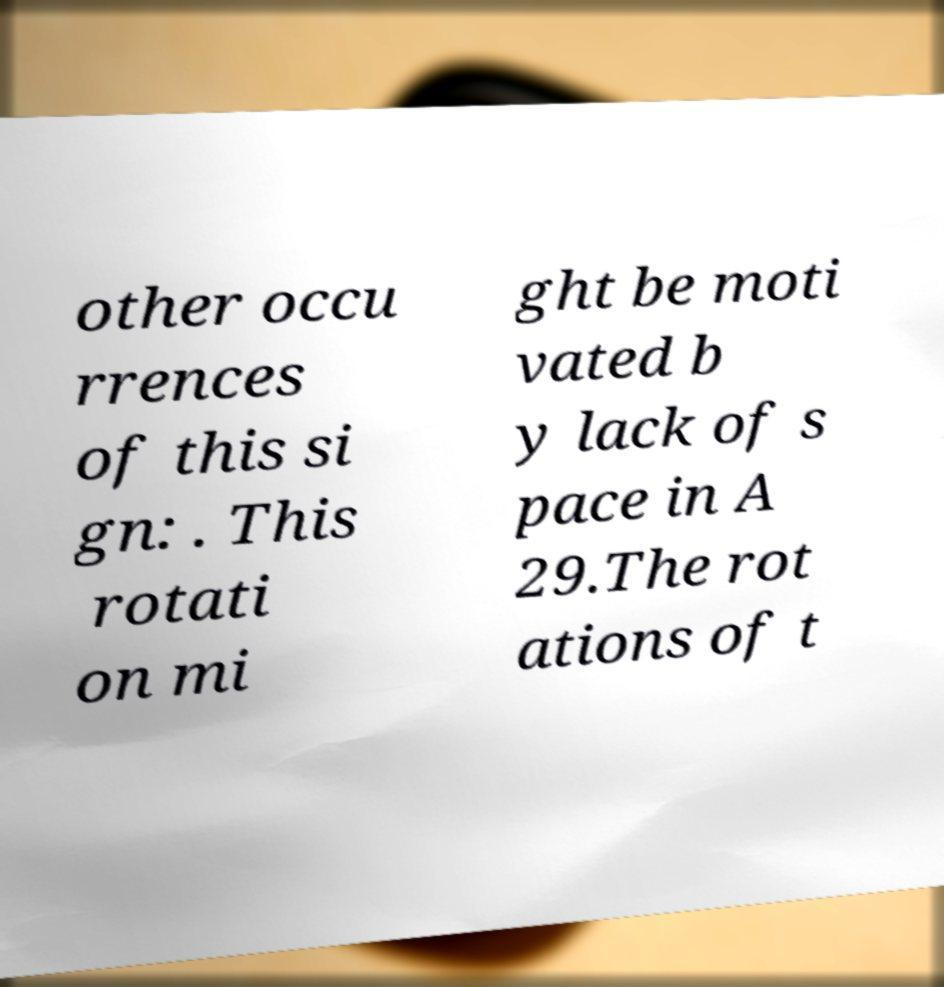Can you read and provide the text displayed in the image?This photo seems to have some interesting text. Can you extract and type it out for me? other occu rrences of this si gn: . This rotati on mi ght be moti vated b y lack of s pace in A 29.The rot ations of t 